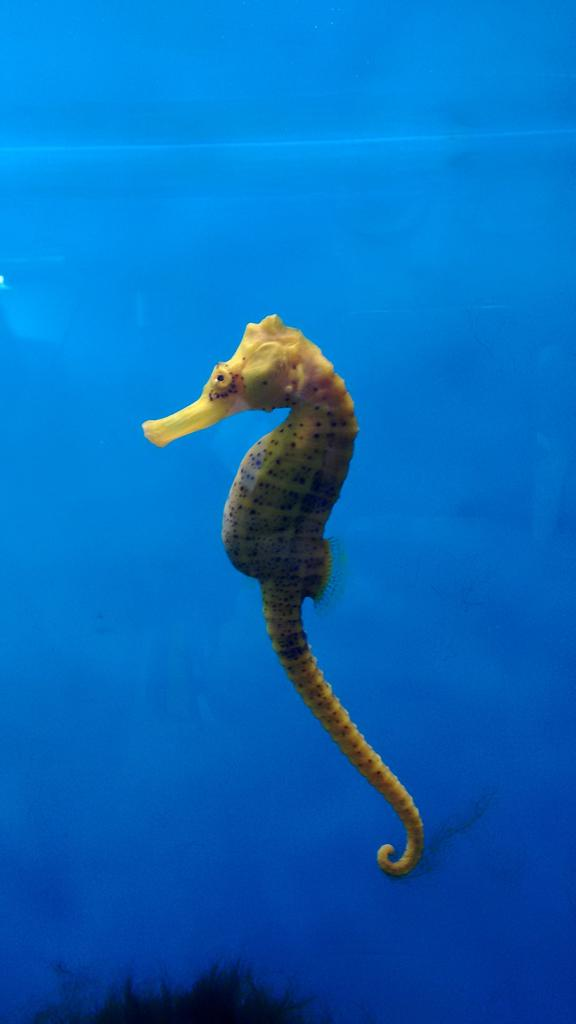What is the main subject in the foreground of the image? There is a seahorse in the foreground of the image. Where is the seahorse located? The seahorse is underwater. What type of coin can be seen in the image? There is no coin present in the image; it features a seahorse underwater. Is the seahorse sleeping in the image? Seahorses do not have eyelids and cannot sleep like humans, so it is not accurate to say the seahorse is sleeping in the image. 